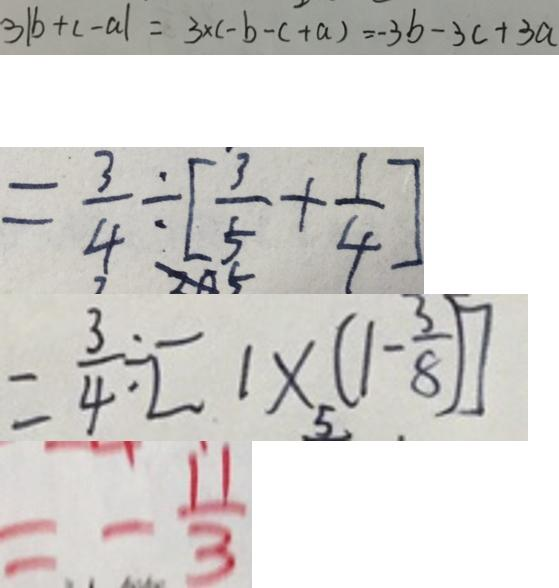<formula> <loc_0><loc_0><loc_500><loc_500>3 \vert b + c - a \vert = 3 \times ( - b - c + a ) = - 3 b - 3 c + 3 a 
 = \frac { 3 } { 4 } \div [ \frac { 3 } { 5 } + \frac { 1 } { 4 } ] 
 = \frac { 3 } { 4 } \div [ 1 \times ( 1 - \frac { 3 } { 8 } ) ] 
 = - \frac { 1 1 } { 3 }</formula> 